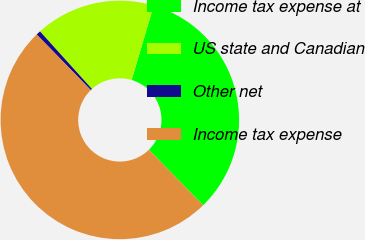Convert chart to OTSL. <chart><loc_0><loc_0><loc_500><loc_500><pie_chart><fcel>Income tax expense at<fcel>US state and Canadian<fcel>Other net<fcel>Income tax expense<nl><fcel>33.13%<fcel>16.26%<fcel>0.61%<fcel>50.0%<nl></chart> 